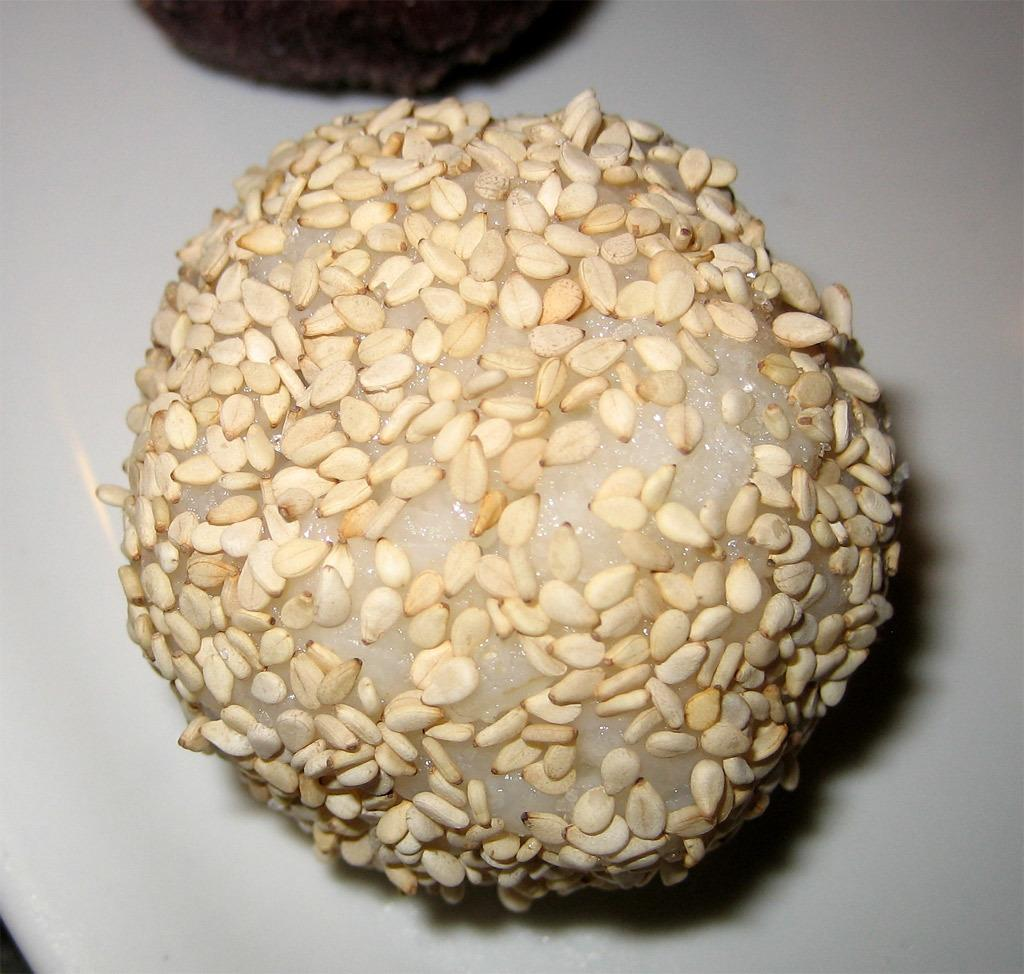What type of food item is visible in the image? There is a food item in the image, but the specific type cannot be determined from the provided facts. What is the color of the black object in the image? The black object in the image is black. What is the color of the surface on which the objects are placed? The objects are on a white color surface. What type of business is being conducted in the image? There is no indication of any business being conducted in the image. Can you tell me how many mittens are visible in the image? There are no mittens present in the image. 